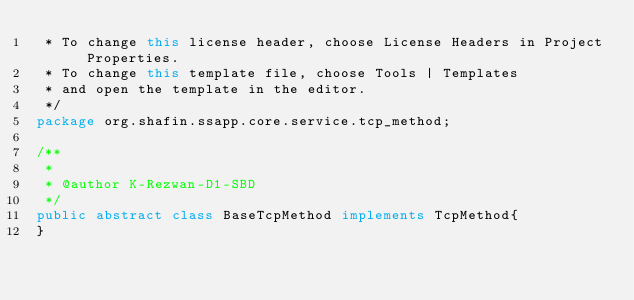<code> <loc_0><loc_0><loc_500><loc_500><_Java_> * To change this license header, choose License Headers in Project Properties.
 * To change this template file, choose Tools | Templates
 * and open the template in the editor.
 */
package org.shafin.ssapp.core.service.tcp_method;

/**
 *
 * @author K-Rezwan-D1-SBD
 */
public abstract class BaseTcpMethod implements TcpMethod{    
}
</code> 